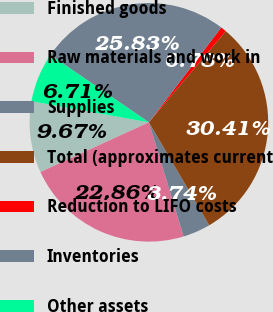Convert chart to OTSL. <chart><loc_0><loc_0><loc_500><loc_500><pie_chart><fcel>Finished goods<fcel>Raw materials and work in<fcel>Supplies<fcel>Total (approximates current<fcel>Reduction to LIFO costs<fcel>Inventories<fcel>Other assets<nl><fcel>9.67%<fcel>22.86%<fcel>3.74%<fcel>30.41%<fcel>0.78%<fcel>25.83%<fcel>6.71%<nl></chart> 